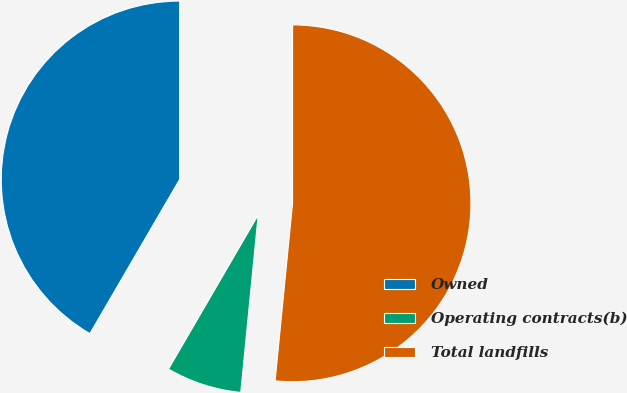Convert chart to OTSL. <chart><loc_0><loc_0><loc_500><loc_500><pie_chart><fcel>Owned<fcel>Operating contracts(b)<fcel>Total landfills<nl><fcel>41.61%<fcel>6.83%<fcel>51.55%<nl></chart> 